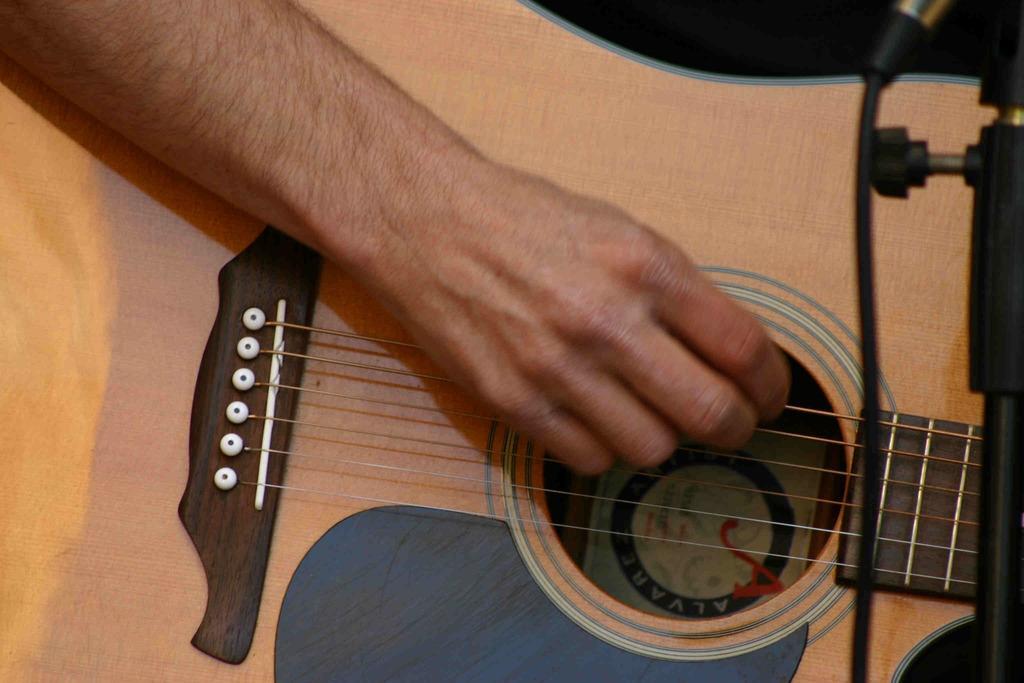Describe this image in one or two sentences. This picture is mainly highlighted with a human's hand playing a guitar. Here we can see a mike. 